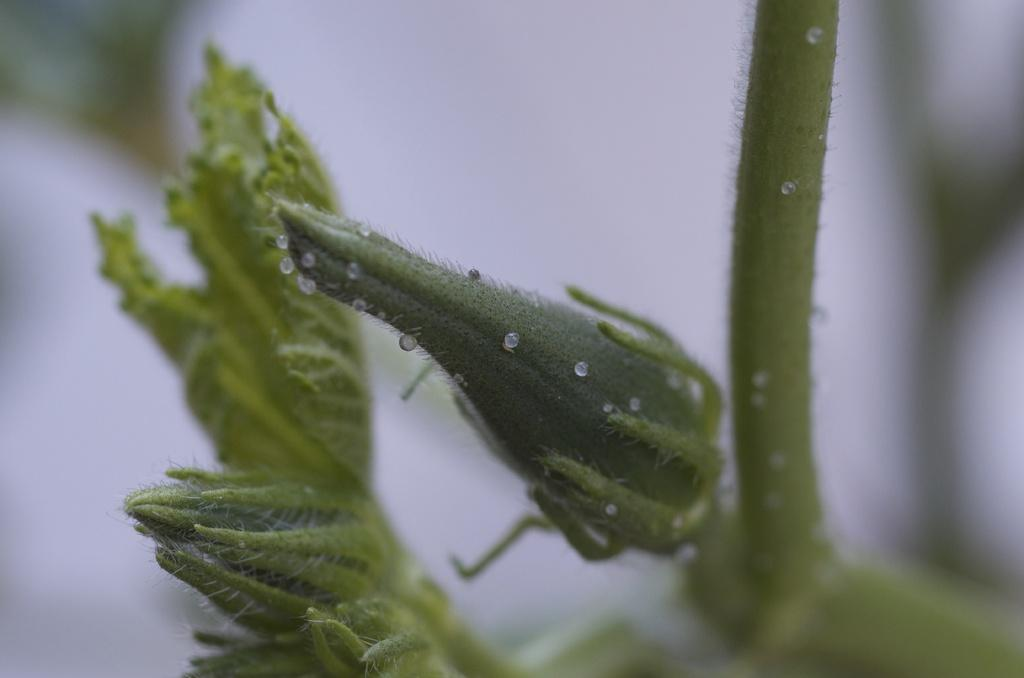What is the main subject of the image? The main subject of the image is a bud. What can be observed on the bud? There are droplets of water on the bud. What else is visible in the background of the image? There is a green leaf in the background of the image. Where is the stem located in the image? The stem is on the right side of the image. What type of belief is represented by the doll in the image? There is no doll present in the image, so it is not possible to determine what belief might be represented. 